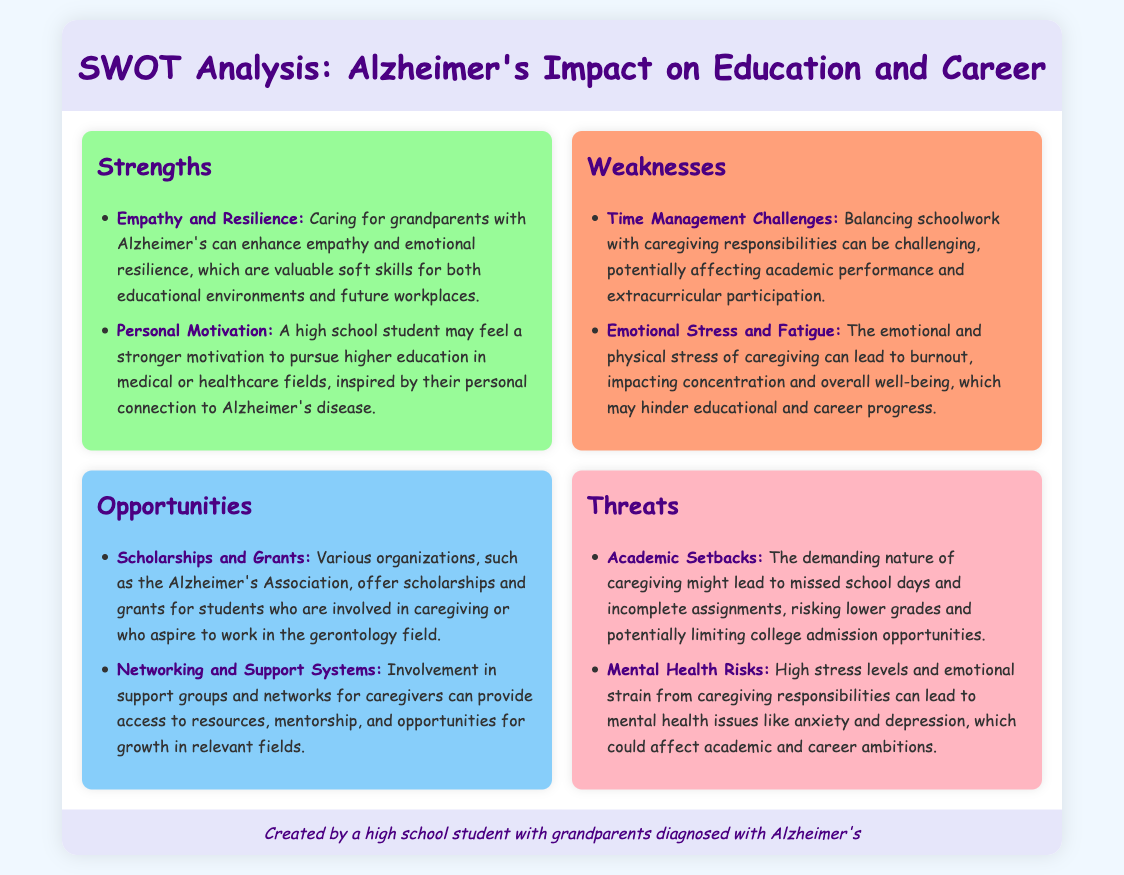What are two strengths mentioned? The strengths listed in the document are "Empathy and Resilience" and "Personal Motivation."
Answer: Empathy and Resilience, Personal Motivation What scholarship opportunities are mentioned? The document states that various organizations, such as the Alzheimer's Association, offer scholarships for students involved in caregiving.
Answer: Scholarships and Grants What is one weakness related to caregiving? One weakness identified is "Time Management Challenges," which can affect academic performance.
Answer: Time Management Challenges What threats are associated with academic performance? The document says that academic setbacks can occur due to missed school days and incomplete assignments.
Answer: Academic Setbacks How many opportunities are discussed in the document? The document includes two opportunities: scholarships and networking.
Answer: Two 